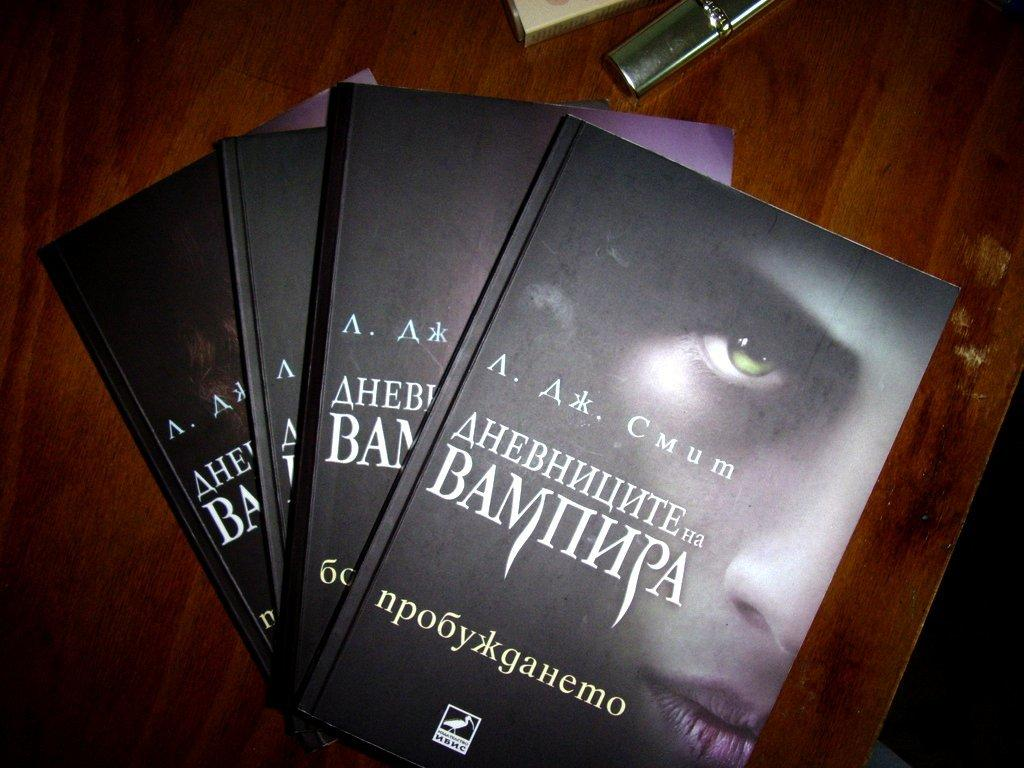What type of objects can be seen in the image? There are books in the image. Can you describe the arrangement of the objects in the image? There are two objects on a wooden surface in the image. How many nerves can be seen in the image? There are no nerves visible in the image. What type of lizards are present in the image? There are no lizards present in the image. 